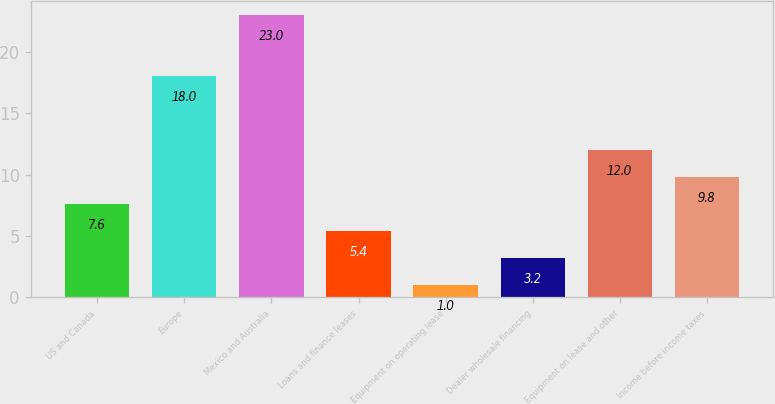<chart> <loc_0><loc_0><loc_500><loc_500><bar_chart><fcel>US and Canada<fcel>Europe<fcel>Mexico and Australia<fcel>Loans and finance leases<fcel>Equipment on operating lease<fcel>Dealer wholesale financing<fcel>Equipment on lease and other<fcel>Income before income taxes<nl><fcel>7.6<fcel>18<fcel>23<fcel>5.4<fcel>1<fcel>3.2<fcel>12<fcel>9.8<nl></chart> 